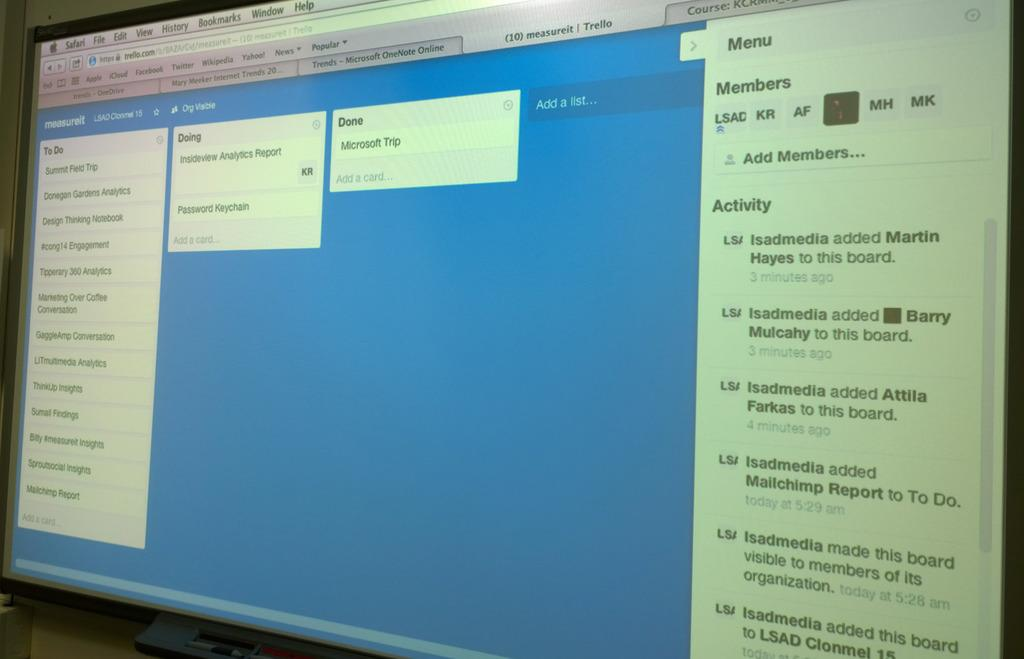<image>
Share a concise interpretation of the image provided. On the computer screen, safari is open to a measureit page. 